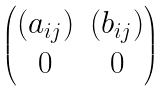<formula> <loc_0><loc_0><loc_500><loc_500>\begin{pmatrix} ( a _ { i j } ) & ( b _ { i j } ) \\ 0 & 0 \end{pmatrix}</formula> 